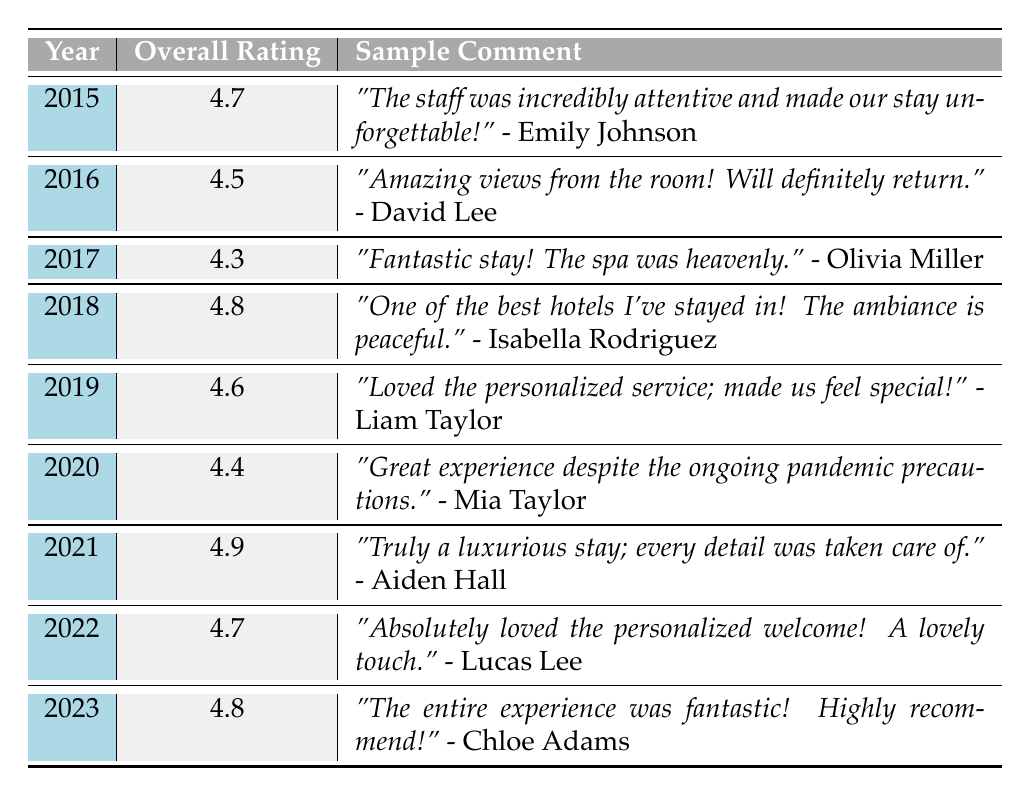What was the overall satisfaction rating in 2021? The table indicates that the overall satisfaction rating for the year 2021 is 4.9.
Answer: 4.9 Which year had the highest overall satisfaction rating? By examining the ratings in the table, 2021 shows the highest rating at 4.9, which is greater than all other years listed.
Answer: 2021 What was the average overall rating from 2015 to 2023? The overall ratings from 2015 to 2023 are: 4.7, 4.5, 4.3, 4.8, 4.6, 4.4, 4.9, 4.7, and 4.8. Adding these gives a total of 36.9, and there are 9 data points, so the average is 36.9 / 9 = 4.1.
Answer: 4.1 Is there any year with an overall rating lower than 4.5? Yes, looking at the table, the years 2015 (4.7), 2016 (4.5), 2017 (4.3), 2018 (4.8), 2019 (4.6), 2020 (4.4), 2021 (4.9), 2022 (4.7), and 2023 (4.8) show that 2017 has a rating less than 4.5.
Answer: Yes How many years had an overall rating of 4.7 or higher? The years with ratings 4.7 or higher are 2015 (4.7), 2018 (4.8), 2019 (4.6), 2021 (4.9), 2022 (4.7), and 2023 (4.8). This makes a total of 6 years.
Answer: 6 What was the comment from Lucas Lee in 2022? The table shows that Lucas Lee's comment in 2022 was, "Absolutely loved the personalized welcome! A lovely touch."
Answer: "Absolutely loved the personalized welcome! A lovely touch." Which guest gave the highest-rated comment in 2018? In 2018, Isabella Rodriguez gave the highest-rated comment with a rating of 5, stating, "One of the best hotels I've stayed in! The ambiance is peaceful."
Answer: Isabella Rodriguez What was the trend in overall ratings from 2015 to 2023? By analyzing the ratings, they started at 4.7 in 2015, fluctuated to 4.3 in 2017, then increased steadily until reaching 4.9 in 2021 and remaining high in the following years; overall, the trend shows improvement over the years.
Answer: Improvement How many total comments were provided across all years? Each year has 3 comments, and there are 9 years in total. Therefore, the total number of comments is 3 comments/year * 9 years = 27 comments.
Answer: 27 Which year had comments about a negative experience with room service? The year 2015 had a comment from Michael Smith mentioning, "The room service was a bit slow, but the quality was excellent," indicating a negative experience.
Answer: 2015 